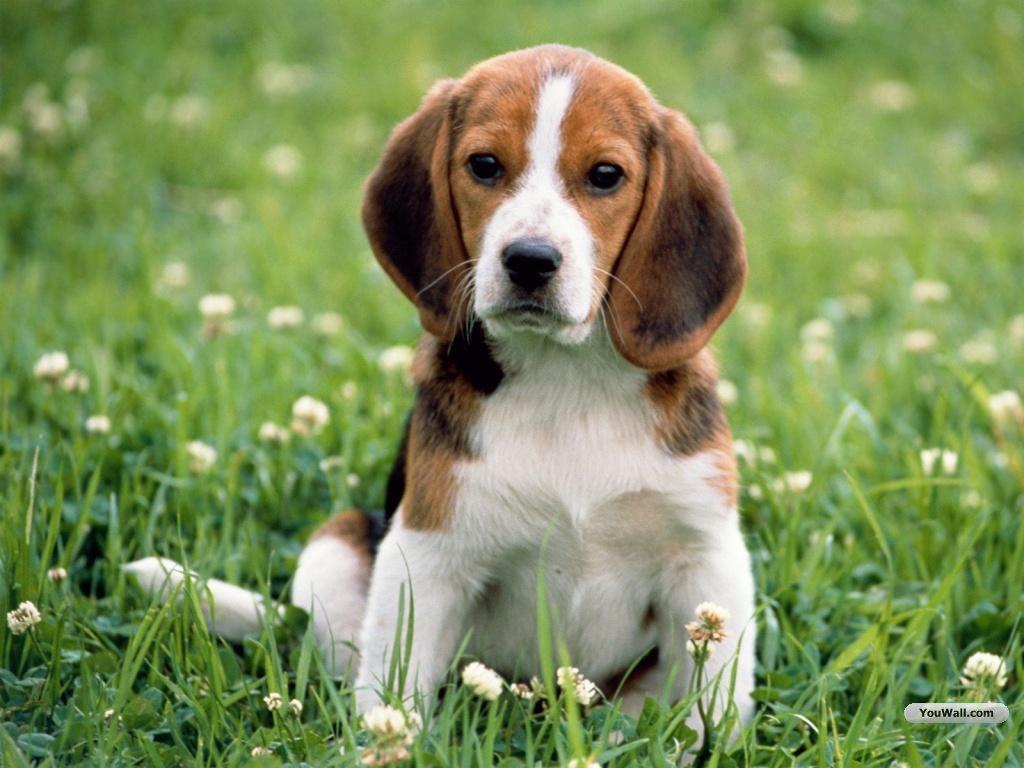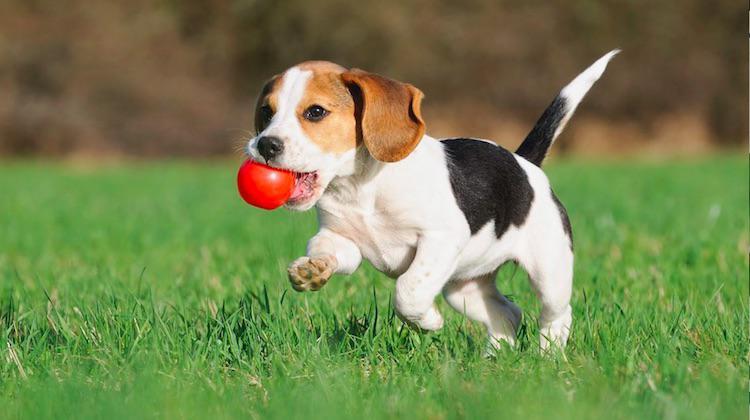The first image is the image on the left, the second image is the image on the right. For the images displayed, is the sentence "There are two dogs" factually correct? Answer yes or no. Yes. 